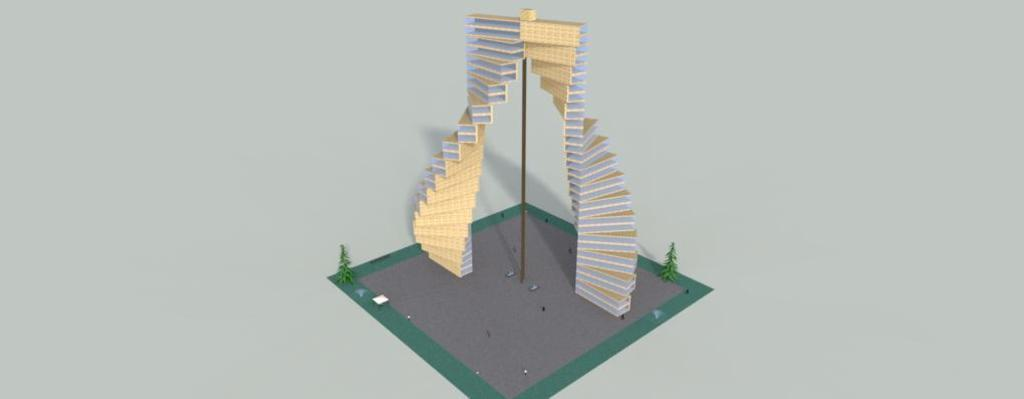What type of image is being described? The image appears to be an edited picture. What is the main subject in the center of the image? There is a geo scraper in the center of the image. What type of window can be seen on the geo scraper in the image? There is no window present on the geo scraper in the image. What type of bun is being used to hold the geo scraper in place? There is no bun present in the image, as it features a geo scraper and not any food items. 